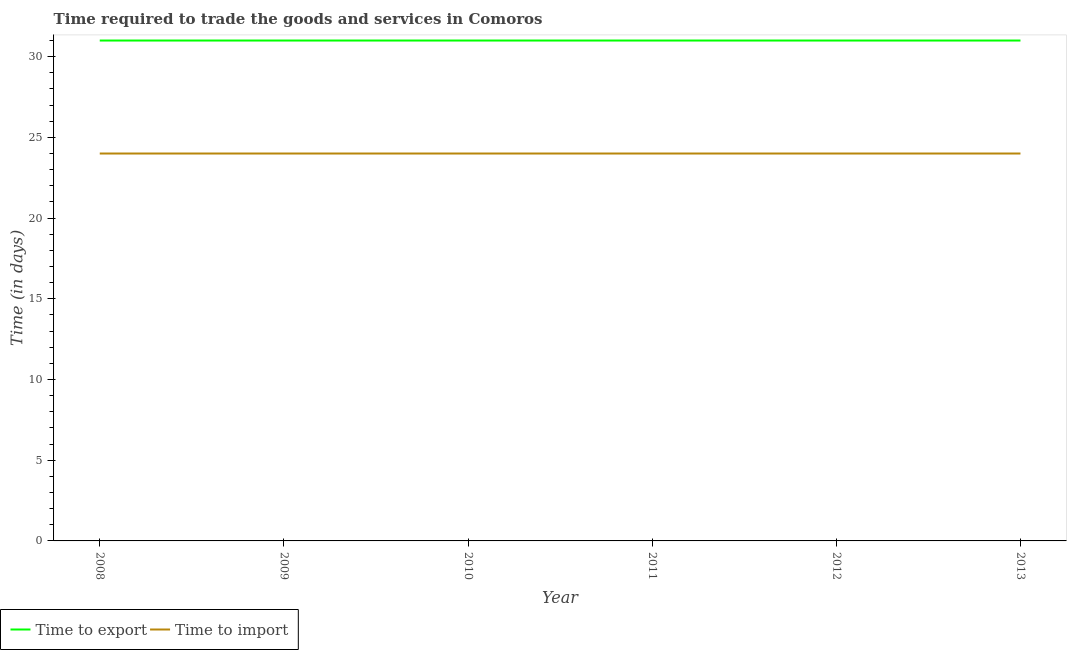Does the line corresponding to time to import intersect with the line corresponding to time to export?
Offer a terse response. No. What is the time to export in 2013?
Offer a terse response. 31. Across all years, what is the maximum time to export?
Provide a short and direct response. 31. Across all years, what is the minimum time to import?
Provide a succinct answer. 24. In which year was the time to export minimum?
Ensure brevity in your answer.  2008. What is the total time to import in the graph?
Provide a short and direct response. 144. What is the difference between the time to export in 2010 and the time to import in 2008?
Offer a very short reply. 7. What is the average time to import per year?
Keep it short and to the point. 24. In the year 2013, what is the difference between the time to export and time to import?
Offer a very short reply. 7. What is the ratio of the time to export in 2012 to that in 2013?
Provide a short and direct response. 1. Is the time to import in 2008 less than that in 2013?
Ensure brevity in your answer.  No. Is the difference between the time to export in 2010 and 2012 greater than the difference between the time to import in 2010 and 2012?
Keep it short and to the point. No. What is the difference between the highest and the second highest time to export?
Give a very brief answer. 0. Is the time to export strictly greater than the time to import over the years?
Give a very brief answer. Yes. Is the time to export strictly less than the time to import over the years?
Ensure brevity in your answer.  No. How many lines are there?
Provide a succinct answer. 2. What is the difference between two consecutive major ticks on the Y-axis?
Offer a terse response. 5. Does the graph contain any zero values?
Provide a succinct answer. No. Where does the legend appear in the graph?
Ensure brevity in your answer.  Bottom left. What is the title of the graph?
Give a very brief answer. Time required to trade the goods and services in Comoros. What is the label or title of the X-axis?
Offer a very short reply. Year. What is the label or title of the Y-axis?
Your answer should be compact. Time (in days). What is the Time (in days) in Time to export in 2008?
Offer a very short reply. 31. What is the Time (in days) in Time to import in 2008?
Give a very brief answer. 24. What is the Time (in days) of Time to export in 2009?
Keep it short and to the point. 31. What is the Time (in days) in Time to export in 2010?
Give a very brief answer. 31. What is the Time (in days) of Time to export in 2011?
Provide a succinct answer. 31. What is the Time (in days) of Time to import in 2011?
Offer a terse response. 24. What is the Time (in days) in Time to import in 2012?
Give a very brief answer. 24. Across all years, what is the minimum Time (in days) of Time to export?
Give a very brief answer. 31. What is the total Time (in days) of Time to export in the graph?
Provide a short and direct response. 186. What is the total Time (in days) in Time to import in the graph?
Keep it short and to the point. 144. What is the difference between the Time (in days) in Time to import in 2008 and that in 2012?
Offer a very short reply. 0. What is the difference between the Time (in days) in Time to export in 2008 and that in 2013?
Offer a terse response. 0. What is the difference between the Time (in days) of Time to import in 2008 and that in 2013?
Keep it short and to the point. 0. What is the difference between the Time (in days) of Time to export in 2009 and that in 2012?
Provide a short and direct response. 0. What is the difference between the Time (in days) of Time to export in 2009 and that in 2013?
Your answer should be very brief. 0. What is the difference between the Time (in days) of Time to import in 2009 and that in 2013?
Provide a short and direct response. 0. What is the difference between the Time (in days) of Time to export in 2010 and that in 2011?
Ensure brevity in your answer.  0. What is the difference between the Time (in days) of Time to export in 2010 and that in 2012?
Provide a short and direct response. 0. What is the difference between the Time (in days) of Time to export in 2010 and that in 2013?
Your answer should be compact. 0. What is the difference between the Time (in days) of Time to import in 2011 and that in 2012?
Your response must be concise. 0. What is the difference between the Time (in days) in Time to export in 2011 and that in 2013?
Give a very brief answer. 0. What is the difference between the Time (in days) of Time to import in 2011 and that in 2013?
Your answer should be compact. 0. What is the difference between the Time (in days) in Time to export in 2012 and that in 2013?
Give a very brief answer. 0. What is the difference between the Time (in days) in Time to export in 2008 and the Time (in days) in Time to import in 2010?
Your response must be concise. 7. What is the difference between the Time (in days) of Time to export in 2008 and the Time (in days) of Time to import in 2013?
Your answer should be very brief. 7. What is the difference between the Time (in days) in Time to export in 2009 and the Time (in days) in Time to import in 2010?
Your answer should be compact. 7. What is the difference between the Time (in days) of Time to export in 2009 and the Time (in days) of Time to import in 2013?
Keep it short and to the point. 7. What is the difference between the Time (in days) of Time to export in 2010 and the Time (in days) of Time to import in 2013?
Provide a short and direct response. 7. What is the average Time (in days) of Time to export per year?
Your answer should be very brief. 31. In the year 2008, what is the difference between the Time (in days) in Time to export and Time (in days) in Time to import?
Provide a succinct answer. 7. In the year 2009, what is the difference between the Time (in days) of Time to export and Time (in days) of Time to import?
Provide a short and direct response. 7. In the year 2010, what is the difference between the Time (in days) in Time to export and Time (in days) in Time to import?
Your response must be concise. 7. In the year 2011, what is the difference between the Time (in days) in Time to export and Time (in days) in Time to import?
Ensure brevity in your answer.  7. In the year 2012, what is the difference between the Time (in days) in Time to export and Time (in days) in Time to import?
Make the answer very short. 7. What is the ratio of the Time (in days) of Time to export in 2008 to that in 2009?
Give a very brief answer. 1. What is the ratio of the Time (in days) in Time to export in 2008 to that in 2010?
Offer a very short reply. 1. What is the ratio of the Time (in days) in Time to import in 2008 to that in 2010?
Your response must be concise. 1. What is the ratio of the Time (in days) of Time to export in 2008 to that in 2011?
Make the answer very short. 1. What is the ratio of the Time (in days) of Time to import in 2008 to that in 2011?
Keep it short and to the point. 1. What is the ratio of the Time (in days) of Time to import in 2008 to that in 2013?
Give a very brief answer. 1. What is the ratio of the Time (in days) in Time to export in 2009 to that in 2010?
Give a very brief answer. 1. What is the ratio of the Time (in days) of Time to export in 2009 to that in 2012?
Make the answer very short. 1. What is the ratio of the Time (in days) in Time to export in 2010 to that in 2013?
Give a very brief answer. 1. What is the ratio of the Time (in days) of Time to import in 2010 to that in 2013?
Keep it short and to the point. 1. What is the ratio of the Time (in days) in Time to import in 2011 to that in 2012?
Make the answer very short. 1. What is the ratio of the Time (in days) of Time to export in 2011 to that in 2013?
Provide a succinct answer. 1. What is the ratio of the Time (in days) in Time to import in 2011 to that in 2013?
Your answer should be very brief. 1. What is the ratio of the Time (in days) of Time to import in 2012 to that in 2013?
Provide a short and direct response. 1. 